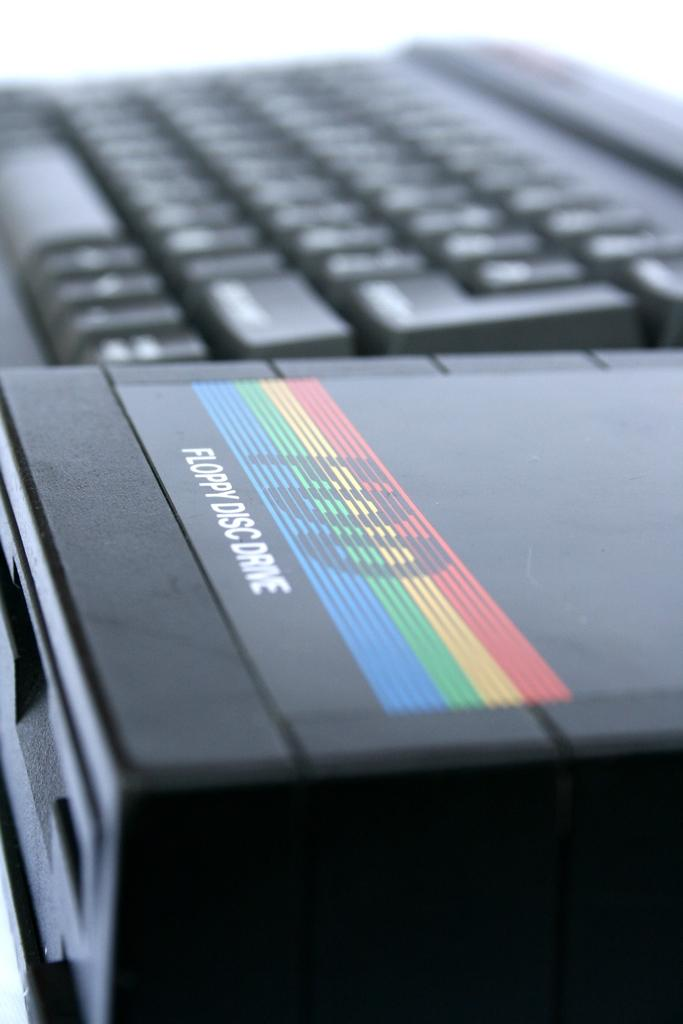<image>
Provide a brief description of the given image. A black computer keyboard next to a floppy disc drive. 